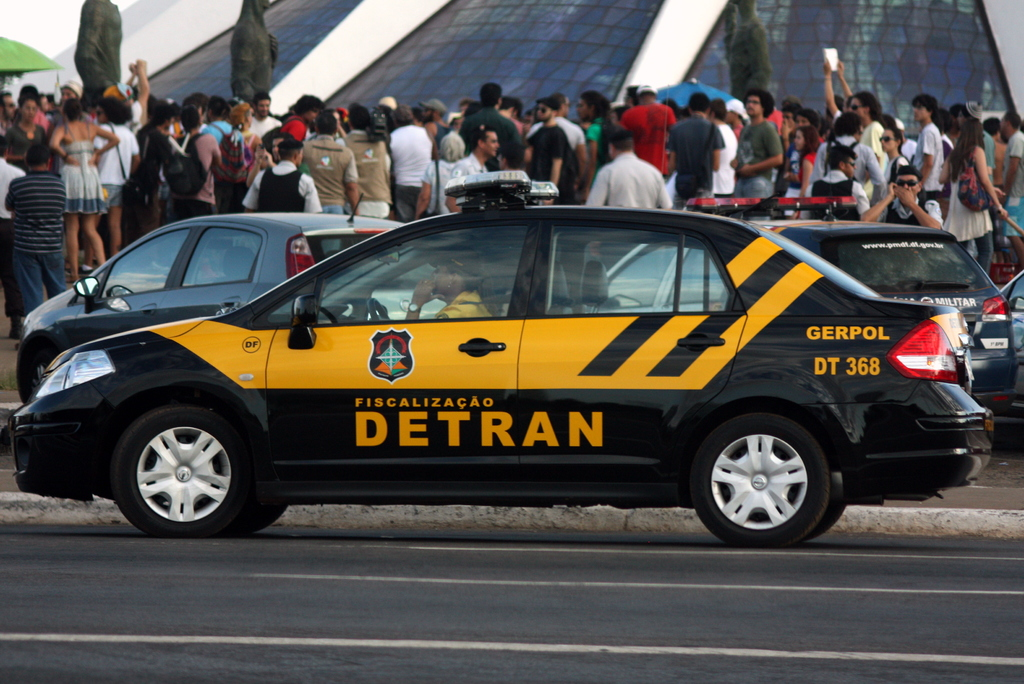Provide a one-sentence caption for the provided image.
Reference OCR token: www.pmflalagne, GERPOL, DT, 368, FISCALIZACAO, DETRAN A black and yellow DETRAN vehicle marked 'Fiscalizacao' is parked on the street, overseeing a busy area filled with bustling crowds, indicating a high level of public activity or event. 